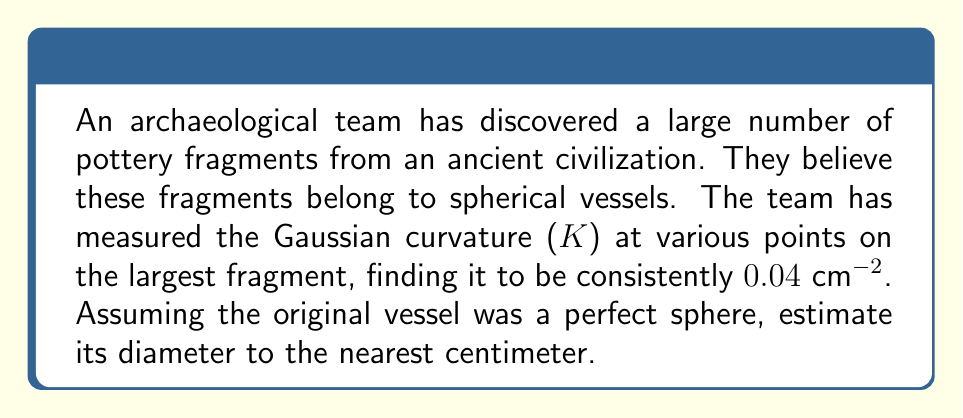Show me your answer to this math problem. To solve this problem, we'll follow these steps:

1) Recall that for a sphere, the Gaussian curvature K is constant and related to the radius R by:

   $$K = \frac{1}{R^2}$$

2) We're given that $K = 0.04 \text{ cm}^{-2}$. Let's substitute this into our equation:

   $$0.04 \text{ cm}^{-2} = \frac{1}{R^2}$$

3) To solve for R, we need to take the reciprocal of both sides and then the square root:

   $$R^2 = \frac{1}{0.04 \text{ cm}^{-2}} = 25 \text{ cm}^2$$

   $$R = \sqrt{25 \text{ cm}^2} = 5 \text{ cm}$$

4) Now that we have the radius, we can calculate the diameter D, which is twice the radius:

   $$D = 2R = 2(5 \text{ cm}) = 10 \text{ cm}$$

5) The question asks for the answer to the nearest centimeter, but our result is already a whole number, so no rounding is necessary.
Answer: The estimated diameter of the original spherical vessel is 10 cm. 